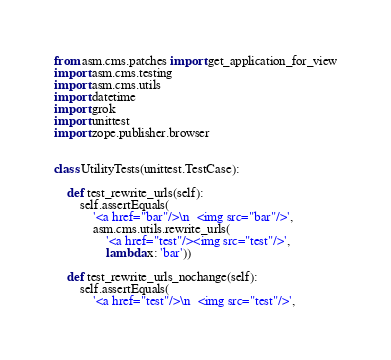Convert code to text. <code><loc_0><loc_0><loc_500><loc_500><_Python_>from asm.cms.patches import get_application_for_view
import asm.cms.testing
import asm.cms.utils
import datetime
import grok
import unittest
import zope.publisher.browser


class UtilityTests(unittest.TestCase):

    def test_rewrite_urls(self):
        self.assertEquals(
            '<a href="bar"/>\n  <img src="bar"/>',
            asm.cms.utils.rewrite_urls(
                '<a href="test"/><img src="test"/>',
                lambda x: 'bar'))

    def test_rewrite_urls_nochange(self):
        self.assertEquals(
            '<a href="test"/>\n  <img src="test"/>',</code> 